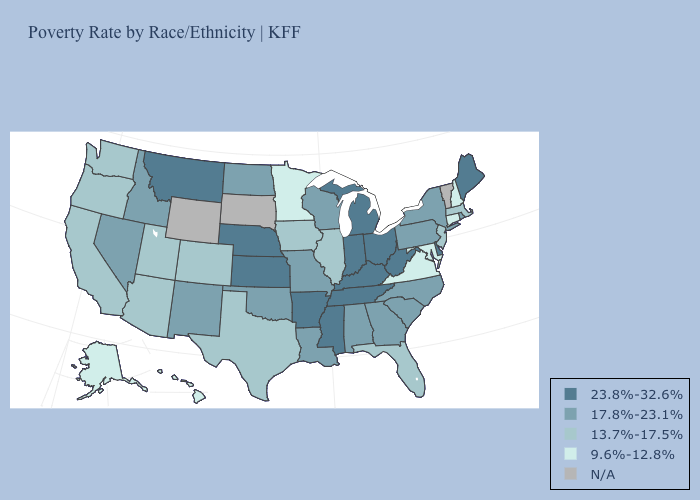What is the highest value in the USA?
Be succinct. 23.8%-32.6%. Name the states that have a value in the range 9.6%-12.8%?
Write a very short answer. Alaska, Connecticut, Hawaii, Maryland, Minnesota, New Hampshire, Virginia. Name the states that have a value in the range 23.8%-32.6%?
Quick response, please. Arkansas, Delaware, Indiana, Kansas, Kentucky, Maine, Michigan, Mississippi, Montana, Nebraska, Ohio, Tennessee, West Virginia. Name the states that have a value in the range 17.8%-23.1%?
Short answer required. Alabama, Georgia, Idaho, Louisiana, Missouri, Nevada, New Mexico, New York, North Carolina, North Dakota, Oklahoma, Pennsylvania, Rhode Island, South Carolina, Wisconsin. What is the value of New Mexico?
Quick response, please. 17.8%-23.1%. Among the states that border Maryland , does West Virginia have the lowest value?
Be succinct. No. What is the lowest value in the USA?
Concise answer only. 9.6%-12.8%. Which states have the highest value in the USA?
Give a very brief answer. Arkansas, Delaware, Indiana, Kansas, Kentucky, Maine, Michigan, Mississippi, Montana, Nebraska, Ohio, Tennessee, West Virginia. What is the highest value in the USA?
Quick response, please. 23.8%-32.6%. Which states have the lowest value in the USA?
Answer briefly. Alaska, Connecticut, Hawaii, Maryland, Minnesota, New Hampshire, Virginia. Name the states that have a value in the range N/A?
Short answer required. South Dakota, Vermont, Wyoming. Name the states that have a value in the range 23.8%-32.6%?
Give a very brief answer. Arkansas, Delaware, Indiana, Kansas, Kentucky, Maine, Michigan, Mississippi, Montana, Nebraska, Ohio, Tennessee, West Virginia. What is the value of Texas?
Write a very short answer. 13.7%-17.5%. 